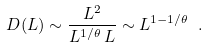<formula> <loc_0><loc_0><loc_500><loc_500>D ( L ) \sim \frac { L ^ { 2 } } { L ^ { 1 / \theta } \, L } \sim L ^ { 1 - 1 / \theta } \ .</formula> 